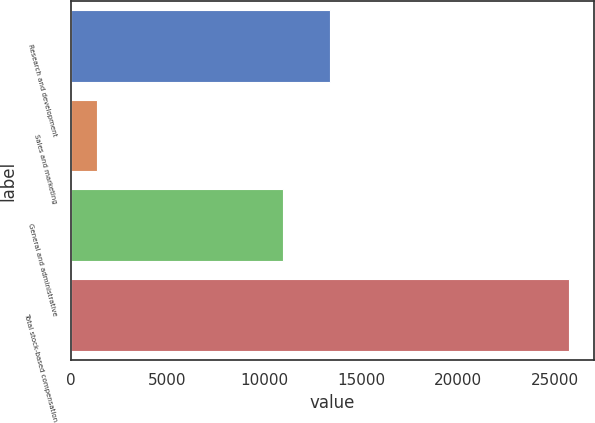Convert chart. <chart><loc_0><loc_0><loc_500><loc_500><bar_chart><fcel>Research and development<fcel>Sales and marketing<fcel>General and administrative<fcel>Total stock-based compensation<nl><fcel>13412.5<fcel>1346<fcel>10973<fcel>25741<nl></chart> 